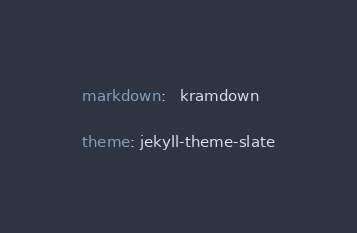Convert code to text. <code><loc_0><loc_0><loc_500><loc_500><_YAML_>markdown:   kramdown

theme: jekyll-theme-slate</code> 